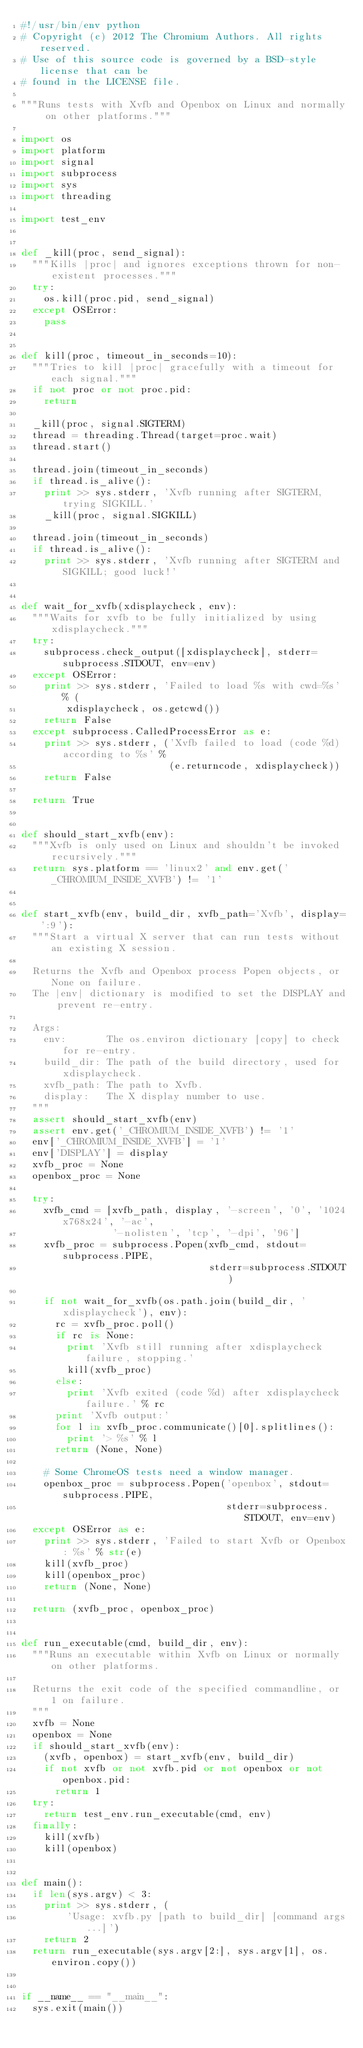Convert code to text. <code><loc_0><loc_0><loc_500><loc_500><_Python_>#!/usr/bin/env python
# Copyright (c) 2012 The Chromium Authors. All rights reserved.
# Use of this source code is governed by a BSD-style license that can be
# found in the LICENSE file.

"""Runs tests with Xvfb and Openbox on Linux and normally on other platforms."""

import os
import platform
import signal
import subprocess
import sys
import threading

import test_env


def _kill(proc, send_signal):
  """Kills |proc| and ignores exceptions thrown for non-existent processes."""
  try:
    os.kill(proc.pid, send_signal)
  except OSError:
    pass


def kill(proc, timeout_in_seconds=10):
  """Tries to kill |proc| gracefully with a timeout for each signal."""
  if not proc or not proc.pid:
    return

  _kill(proc, signal.SIGTERM)
  thread = threading.Thread(target=proc.wait)
  thread.start()

  thread.join(timeout_in_seconds)
  if thread.is_alive():
    print >> sys.stderr, 'Xvfb running after SIGTERM, trying SIGKILL.'
    _kill(proc, signal.SIGKILL)

  thread.join(timeout_in_seconds)
  if thread.is_alive():
    print >> sys.stderr, 'Xvfb running after SIGTERM and SIGKILL; good luck!'


def wait_for_xvfb(xdisplaycheck, env):
  """Waits for xvfb to be fully initialized by using xdisplaycheck."""
  try:
    subprocess.check_output([xdisplaycheck], stderr=subprocess.STDOUT, env=env)
  except OSError:
    print >> sys.stderr, 'Failed to load %s with cwd=%s' % (
        xdisplaycheck, os.getcwd())
    return False
  except subprocess.CalledProcessError as e:
    print >> sys.stderr, ('Xvfb failed to load (code %d) according to %s' %
                          (e.returncode, xdisplaycheck))
    return False

  return True


def should_start_xvfb(env):
  """Xvfb is only used on Linux and shouldn't be invoked recursively."""
  return sys.platform == 'linux2' and env.get('_CHROMIUM_INSIDE_XVFB') != '1'


def start_xvfb(env, build_dir, xvfb_path='Xvfb', display=':9'):
  """Start a virtual X server that can run tests without an existing X session.

  Returns the Xvfb and Openbox process Popen objects, or None on failure.
  The |env| dictionary is modified to set the DISPLAY and prevent re-entry.

  Args:
    env:       The os.environ dictionary [copy] to check for re-entry.
    build_dir: The path of the build directory, used for xdisplaycheck.
    xvfb_path: The path to Xvfb.
    display:   The X display number to use.
  """
  assert should_start_xvfb(env)
  assert env.get('_CHROMIUM_INSIDE_XVFB') != '1'
  env['_CHROMIUM_INSIDE_XVFB'] = '1'
  env['DISPLAY'] = display
  xvfb_proc = None
  openbox_proc = None

  try:
    xvfb_cmd = [xvfb_path, display, '-screen', '0', '1024x768x24', '-ac',
                '-nolisten', 'tcp', '-dpi', '96']
    xvfb_proc = subprocess.Popen(xvfb_cmd, stdout=subprocess.PIPE,
                                 stderr=subprocess.STDOUT)

    if not wait_for_xvfb(os.path.join(build_dir, 'xdisplaycheck'), env):
      rc = xvfb_proc.poll()
      if rc is None:
        print 'Xvfb still running after xdisplaycheck failure, stopping.'
        kill(xvfb_proc)
      else:
        print 'Xvfb exited (code %d) after xdisplaycheck failure.' % rc
      print 'Xvfb output:'
      for l in xvfb_proc.communicate()[0].splitlines():
        print '> %s' % l
      return (None, None)

    # Some ChromeOS tests need a window manager.
    openbox_proc = subprocess.Popen('openbox', stdout=subprocess.PIPE,
                                    stderr=subprocess.STDOUT, env=env)
  except OSError as e:
    print >> sys.stderr, 'Failed to start Xvfb or Openbox: %s' % str(e)
    kill(xvfb_proc)
    kill(openbox_proc)
    return (None, None)

  return (xvfb_proc, openbox_proc)


def run_executable(cmd, build_dir, env):
  """Runs an executable within Xvfb on Linux or normally on other platforms.

  Returns the exit code of the specified commandline, or 1 on failure.
  """
  xvfb = None
  openbox = None
  if should_start_xvfb(env):
    (xvfb, openbox) = start_xvfb(env, build_dir)
    if not xvfb or not xvfb.pid or not openbox or not openbox.pid:
      return 1
  try:
    return test_env.run_executable(cmd, env)
  finally:
    kill(xvfb)
    kill(openbox)


def main():
  if len(sys.argv) < 3:
    print >> sys.stderr, (
        'Usage: xvfb.py [path to build_dir] [command args...]')
    return 2
  return run_executable(sys.argv[2:], sys.argv[1], os.environ.copy())


if __name__ == "__main__":
  sys.exit(main())
</code> 